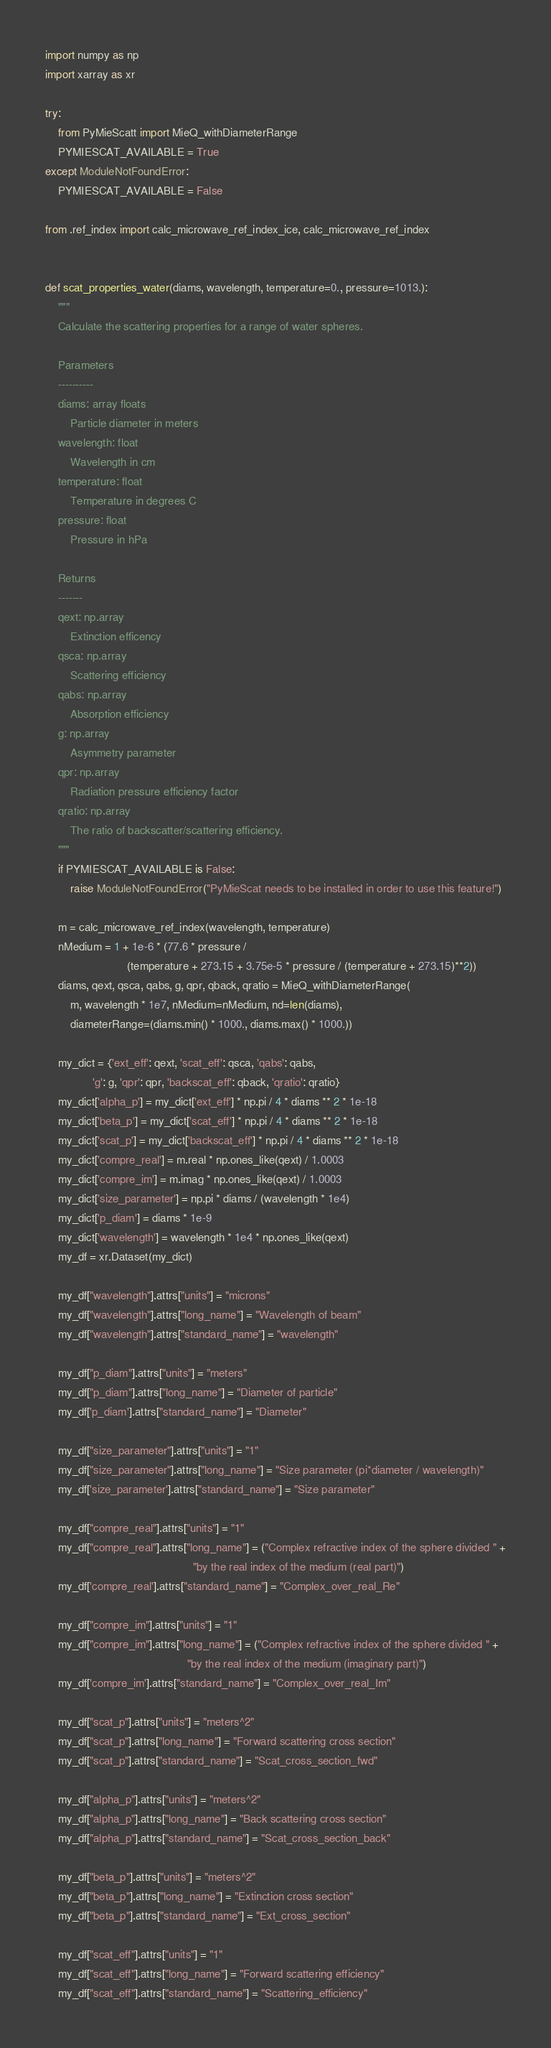<code> <loc_0><loc_0><loc_500><loc_500><_Python_>import numpy as np
import xarray as xr

try:
    from PyMieScatt import MieQ_withDiameterRange
    PYMIESCAT_AVAILABLE = True
except ModuleNotFoundError:
    PYMIESCAT_AVAILABLE = False

from .ref_index import calc_microwave_ref_index_ice, calc_microwave_ref_index


def scat_properties_water(diams, wavelength, temperature=0., pressure=1013.):
    """
    Calculate the scattering properties for a range of water spheres.

    Parameters
    ----------
    diams: array floats
        Particle diameter in meters
    wavelength: float
        Wavelength in cm
    temperature: float
        Temperature in degrees C
    pressure: float
        Pressure in hPa

    Returns
    -------
    qext: np.array
        Extinction efficency
    qsca: np.array
        Scattering efficiency
    qabs: np.array
        Absorption efficiency
    g: np.array
        Asymmetry parameter
    qpr: np.array
        Radiation pressure efficiency factor
    qratio: np.array
        The ratio of backscatter/scattering efficiency.
    """
    if PYMIESCAT_AVAILABLE is False:
        raise ModuleNotFoundError("PyMieScat needs to be installed in order to use this feature!")

    m = calc_microwave_ref_index(wavelength, temperature)
    nMedium = 1 + 1e-6 * (77.6 * pressure /
                          (temperature + 273.15 + 3.75e-5 * pressure / (temperature + 273.15)**2))
    diams, qext, qsca, qabs, g, qpr, qback, qratio = MieQ_withDiameterRange(
        m, wavelength * 1e7, nMedium=nMedium, nd=len(diams),
        diameterRange=(diams.min() * 1000., diams.max() * 1000.))

    my_dict = {'ext_eff': qext, 'scat_eff': qsca, 'qabs': qabs,
               'g': g, 'qpr': qpr, 'backscat_eff': qback, 'qratio': qratio}
    my_dict['alpha_p'] = my_dict['ext_eff'] * np.pi / 4 * diams ** 2 * 1e-18
    my_dict['beta_p'] = my_dict['scat_eff'] * np.pi / 4 * diams ** 2 * 1e-18
    my_dict['scat_p'] = my_dict['backscat_eff'] * np.pi / 4 * diams ** 2 * 1e-18
    my_dict['compre_real'] = m.real * np.ones_like(qext) / 1.0003
    my_dict['compre_im'] = m.imag * np.ones_like(qext) / 1.0003
    my_dict['size_parameter'] = np.pi * diams / (wavelength * 1e4)
    my_dict['p_diam'] = diams * 1e-9
    my_dict['wavelength'] = wavelength * 1e4 * np.ones_like(qext)
    my_df = xr.Dataset(my_dict)

    my_df["wavelength"].attrs["units"] = "microns"
    my_df["wavelength"].attrs["long_name"] = "Wavelength of beam"
    my_df["wavelength"].attrs["standard_name"] = "wavelength"

    my_df["p_diam"].attrs["units"] = "meters"
    my_df["p_diam"].attrs["long_name"] = "Diameter of particle"
    my_df['p_diam'].attrs["standard_name"] = "Diameter"

    my_df["size_parameter"].attrs["units"] = "1"
    my_df["size_parameter"].attrs["long_name"] = "Size parameter (pi*diameter / wavelength)"
    my_df['size_parameter'].attrs["standard_name"] = "Size parameter"

    my_df["compre_real"].attrs["units"] = "1"
    my_df["compre_real"].attrs["long_name"] = ("Complex refractive index of the sphere divided " +
                                               "by the real index of the medium (real part)")
    my_df['compre_real'].attrs["standard_name"] = "Complex_over_real_Re"

    my_df["compre_im"].attrs["units"] = "1"
    my_df["compre_im"].attrs["long_name"] = ("Complex refractive index of the sphere divided " +
                                             "by the real index of the medium (imaginary part)")
    my_df['compre_im'].attrs["standard_name"] = "Complex_over_real_Im"

    my_df["scat_p"].attrs["units"] = "meters^2"
    my_df["scat_p"].attrs["long_name"] = "Forward scattering cross section"
    my_df["scat_p"].attrs["standard_name"] = "Scat_cross_section_fwd"

    my_df["alpha_p"].attrs["units"] = "meters^2"
    my_df["alpha_p"].attrs["long_name"] = "Back scattering cross section"
    my_df["alpha_p"].attrs["standard_name"] = "Scat_cross_section_back"

    my_df["beta_p"].attrs["units"] = "meters^2"
    my_df["beta_p"].attrs["long_name"] = "Extinction cross section"
    my_df["beta_p"].attrs["standard_name"] = "Ext_cross_section"

    my_df["scat_eff"].attrs["units"] = "1"
    my_df["scat_eff"].attrs["long_name"] = "Forward scattering efficiency"
    my_df["scat_eff"].attrs["standard_name"] = "Scattering_efficiency"
</code> 